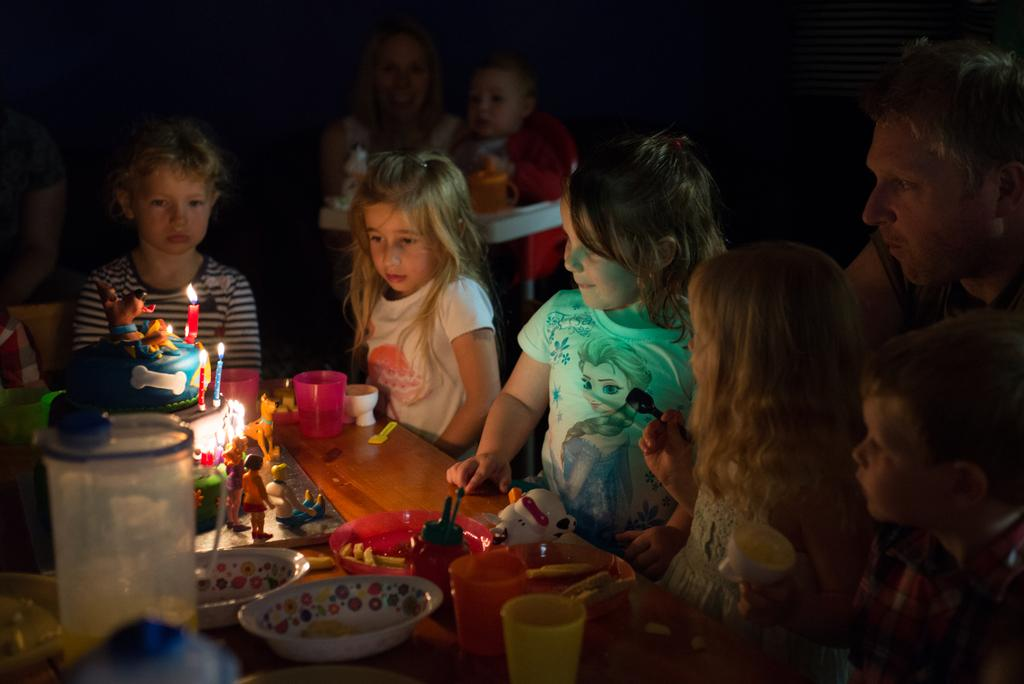Who or what can be seen in the image? There are people in the image. What is present on the table in the image? There is a table in the image, and on it, there are glasses, plates, bowls, toys, a cake, and candles. What might be used for drinking or eating in the image? The glasses, plates, and bowls on the table might be used for drinking or eating. What is the purpose of the candles on the table? The candles on the table might be used for decoration or to celebrate a special occasion. What type of fog can be seen in the image? There is no fog present in the image. What is the purpose of the mailbox in the image? There is no mailbox present in the image. 